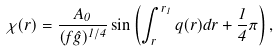Convert formula to latex. <formula><loc_0><loc_0><loc_500><loc_500>\chi ( r ) = \frac { A _ { 0 } } { ( f \hat { g } ) ^ { 1 / 4 } } \sin \left ( \int _ { r } ^ { r _ { 1 } } q ( r ) d r + \frac { 1 } { 4 } \pi \right ) ,</formula> 